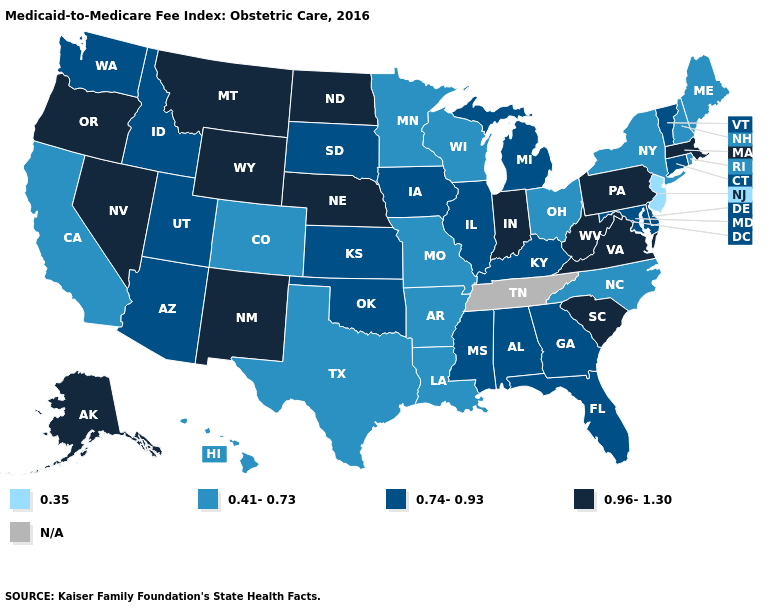Which states hav the highest value in the South?
Be succinct. South Carolina, Virginia, West Virginia. Name the states that have a value in the range 0.96-1.30?
Answer briefly. Alaska, Indiana, Massachusetts, Montana, Nebraska, Nevada, New Mexico, North Dakota, Oregon, Pennsylvania, South Carolina, Virginia, West Virginia, Wyoming. What is the lowest value in the USA?
Answer briefly. 0.35. How many symbols are there in the legend?
Concise answer only. 5. What is the value of Connecticut?
Answer briefly. 0.74-0.93. Name the states that have a value in the range N/A?
Short answer required. Tennessee. Name the states that have a value in the range 0.96-1.30?
Give a very brief answer. Alaska, Indiana, Massachusetts, Montana, Nebraska, Nevada, New Mexico, North Dakota, Oregon, Pennsylvania, South Carolina, Virginia, West Virginia, Wyoming. Name the states that have a value in the range 0.96-1.30?
Give a very brief answer. Alaska, Indiana, Massachusetts, Montana, Nebraska, Nevada, New Mexico, North Dakota, Oregon, Pennsylvania, South Carolina, Virginia, West Virginia, Wyoming. Name the states that have a value in the range 0.41-0.73?
Quick response, please. Arkansas, California, Colorado, Hawaii, Louisiana, Maine, Minnesota, Missouri, New Hampshire, New York, North Carolina, Ohio, Rhode Island, Texas, Wisconsin. Does New Jersey have the lowest value in the USA?
Concise answer only. Yes. Which states have the highest value in the USA?
Be succinct. Alaska, Indiana, Massachusetts, Montana, Nebraska, Nevada, New Mexico, North Dakota, Oregon, Pennsylvania, South Carolina, Virginia, West Virginia, Wyoming. What is the value of Tennessee?
Answer briefly. N/A. 